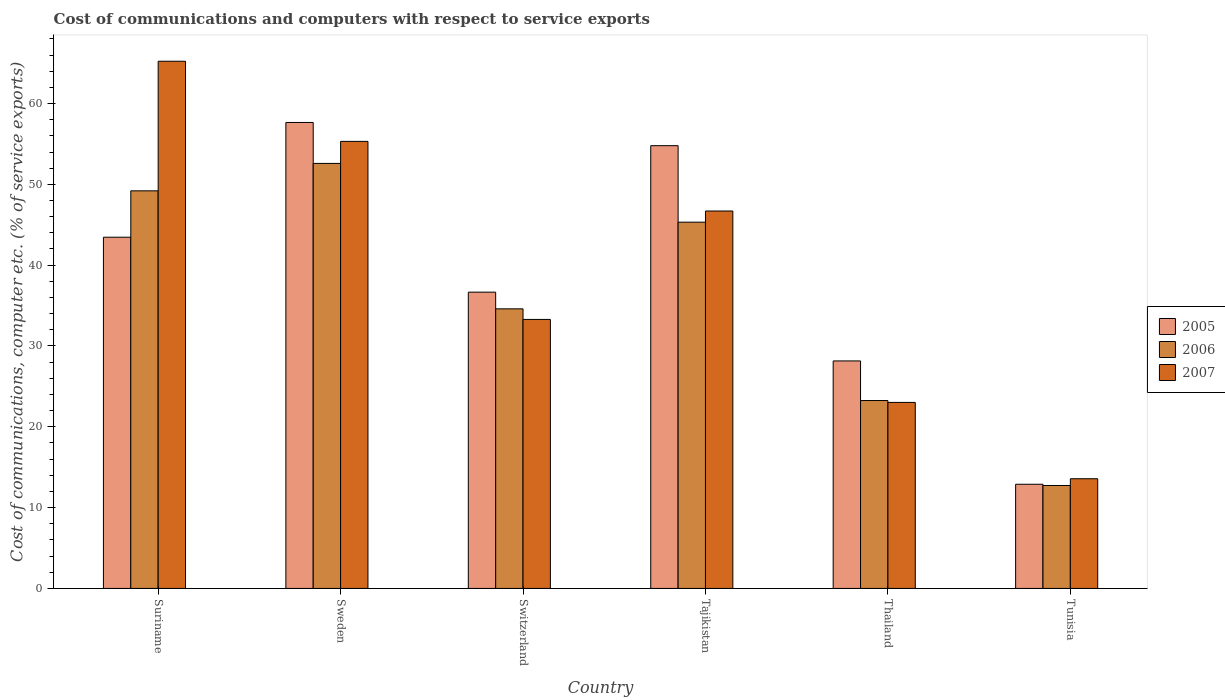How many different coloured bars are there?
Offer a very short reply. 3. How many groups of bars are there?
Your answer should be compact. 6. What is the label of the 6th group of bars from the left?
Give a very brief answer. Tunisia. In how many cases, is the number of bars for a given country not equal to the number of legend labels?
Offer a very short reply. 0. What is the cost of communications and computers in 2005 in Switzerland?
Ensure brevity in your answer.  36.66. Across all countries, what is the maximum cost of communications and computers in 2005?
Your answer should be compact. 57.66. Across all countries, what is the minimum cost of communications and computers in 2007?
Make the answer very short. 13.57. In which country was the cost of communications and computers in 2007 maximum?
Ensure brevity in your answer.  Suriname. In which country was the cost of communications and computers in 2005 minimum?
Give a very brief answer. Tunisia. What is the total cost of communications and computers in 2007 in the graph?
Offer a terse response. 237.13. What is the difference between the cost of communications and computers in 2006 in Thailand and that in Tunisia?
Offer a very short reply. 10.51. What is the difference between the cost of communications and computers in 2006 in Tunisia and the cost of communications and computers in 2005 in Thailand?
Offer a very short reply. -15.41. What is the average cost of communications and computers in 2007 per country?
Keep it short and to the point. 39.52. What is the difference between the cost of communications and computers of/in 2006 and cost of communications and computers of/in 2007 in Tajikistan?
Ensure brevity in your answer.  -1.38. In how many countries, is the cost of communications and computers in 2006 greater than 18 %?
Provide a short and direct response. 5. What is the ratio of the cost of communications and computers in 2005 in Switzerland to that in Tajikistan?
Provide a succinct answer. 0.67. Is the cost of communications and computers in 2005 in Suriname less than that in Thailand?
Provide a succinct answer. No. What is the difference between the highest and the second highest cost of communications and computers in 2007?
Give a very brief answer. 18.53. What is the difference between the highest and the lowest cost of communications and computers in 2006?
Keep it short and to the point. 39.85. Is the sum of the cost of communications and computers in 2006 in Suriname and Sweden greater than the maximum cost of communications and computers in 2005 across all countries?
Keep it short and to the point. Yes. What does the 1st bar from the left in Tunisia represents?
Give a very brief answer. 2005. What does the 3rd bar from the right in Sweden represents?
Offer a very short reply. 2005. Is it the case that in every country, the sum of the cost of communications and computers in 2006 and cost of communications and computers in 2007 is greater than the cost of communications and computers in 2005?
Your answer should be very brief. Yes. How many bars are there?
Give a very brief answer. 18. Are all the bars in the graph horizontal?
Provide a succinct answer. No. How many countries are there in the graph?
Provide a succinct answer. 6. What is the difference between two consecutive major ticks on the Y-axis?
Keep it short and to the point. 10. Are the values on the major ticks of Y-axis written in scientific E-notation?
Keep it short and to the point. No. Does the graph contain grids?
Offer a terse response. No. How many legend labels are there?
Provide a short and direct response. 3. What is the title of the graph?
Your answer should be very brief. Cost of communications and computers with respect to service exports. Does "1982" appear as one of the legend labels in the graph?
Provide a short and direct response. No. What is the label or title of the X-axis?
Keep it short and to the point. Country. What is the label or title of the Y-axis?
Offer a very short reply. Cost of communications, computer etc. (% of service exports). What is the Cost of communications, computer etc. (% of service exports) of 2005 in Suriname?
Offer a very short reply. 43.46. What is the Cost of communications, computer etc. (% of service exports) in 2006 in Suriname?
Your answer should be very brief. 49.2. What is the Cost of communications, computer etc. (% of service exports) in 2007 in Suriname?
Give a very brief answer. 65.23. What is the Cost of communications, computer etc. (% of service exports) of 2005 in Sweden?
Provide a succinct answer. 57.66. What is the Cost of communications, computer etc. (% of service exports) of 2006 in Sweden?
Offer a very short reply. 52.59. What is the Cost of communications, computer etc. (% of service exports) of 2007 in Sweden?
Provide a succinct answer. 55.32. What is the Cost of communications, computer etc. (% of service exports) in 2005 in Switzerland?
Give a very brief answer. 36.66. What is the Cost of communications, computer etc. (% of service exports) in 2006 in Switzerland?
Provide a succinct answer. 34.6. What is the Cost of communications, computer etc. (% of service exports) in 2007 in Switzerland?
Provide a short and direct response. 33.29. What is the Cost of communications, computer etc. (% of service exports) of 2005 in Tajikistan?
Provide a short and direct response. 54.78. What is the Cost of communications, computer etc. (% of service exports) in 2006 in Tajikistan?
Ensure brevity in your answer.  45.32. What is the Cost of communications, computer etc. (% of service exports) of 2007 in Tajikistan?
Your answer should be compact. 46.7. What is the Cost of communications, computer etc. (% of service exports) of 2005 in Thailand?
Your response must be concise. 28.15. What is the Cost of communications, computer etc. (% of service exports) of 2006 in Thailand?
Give a very brief answer. 23.25. What is the Cost of communications, computer etc. (% of service exports) in 2007 in Thailand?
Provide a succinct answer. 23.02. What is the Cost of communications, computer etc. (% of service exports) of 2005 in Tunisia?
Provide a succinct answer. 12.89. What is the Cost of communications, computer etc. (% of service exports) in 2006 in Tunisia?
Your answer should be compact. 12.74. What is the Cost of communications, computer etc. (% of service exports) of 2007 in Tunisia?
Your answer should be compact. 13.57. Across all countries, what is the maximum Cost of communications, computer etc. (% of service exports) in 2005?
Make the answer very short. 57.66. Across all countries, what is the maximum Cost of communications, computer etc. (% of service exports) of 2006?
Your answer should be very brief. 52.59. Across all countries, what is the maximum Cost of communications, computer etc. (% of service exports) of 2007?
Make the answer very short. 65.23. Across all countries, what is the minimum Cost of communications, computer etc. (% of service exports) of 2005?
Your answer should be very brief. 12.89. Across all countries, what is the minimum Cost of communications, computer etc. (% of service exports) of 2006?
Your answer should be compact. 12.74. Across all countries, what is the minimum Cost of communications, computer etc. (% of service exports) in 2007?
Make the answer very short. 13.57. What is the total Cost of communications, computer etc. (% of service exports) in 2005 in the graph?
Your response must be concise. 233.6. What is the total Cost of communications, computer etc. (% of service exports) in 2006 in the graph?
Offer a very short reply. 217.69. What is the total Cost of communications, computer etc. (% of service exports) in 2007 in the graph?
Provide a succinct answer. 237.13. What is the difference between the Cost of communications, computer etc. (% of service exports) of 2005 in Suriname and that in Sweden?
Your answer should be compact. -14.2. What is the difference between the Cost of communications, computer etc. (% of service exports) in 2006 in Suriname and that in Sweden?
Make the answer very short. -3.39. What is the difference between the Cost of communications, computer etc. (% of service exports) in 2007 in Suriname and that in Sweden?
Make the answer very short. 9.92. What is the difference between the Cost of communications, computer etc. (% of service exports) of 2005 in Suriname and that in Switzerland?
Make the answer very short. 6.8. What is the difference between the Cost of communications, computer etc. (% of service exports) in 2006 in Suriname and that in Switzerland?
Offer a terse response. 14.6. What is the difference between the Cost of communications, computer etc. (% of service exports) of 2007 in Suriname and that in Switzerland?
Give a very brief answer. 31.95. What is the difference between the Cost of communications, computer etc. (% of service exports) of 2005 in Suriname and that in Tajikistan?
Provide a short and direct response. -11.33. What is the difference between the Cost of communications, computer etc. (% of service exports) in 2006 in Suriname and that in Tajikistan?
Offer a terse response. 3.88. What is the difference between the Cost of communications, computer etc. (% of service exports) in 2007 in Suriname and that in Tajikistan?
Ensure brevity in your answer.  18.53. What is the difference between the Cost of communications, computer etc. (% of service exports) in 2005 in Suriname and that in Thailand?
Give a very brief answer. 15.31. What is the difference between the Cost of communications, computer etc. (% of service exports) in 2006 in Suriname and that in Thailand?
Provide a short and direct response. 25.95. What is the difference between the Cost of communications, computer etc. (% of service exports) in 2007 in Suriname and that in Thailand?
Your response must be concise. 42.22. What is the difference between the Cost of communications, computer etc. (% of service exports) in 2005 in Suriname and that in Tunisia?
Offer a very short reply. 30.57. What is the difference between the Cost of communications, computer etc. (% of service exports) in 2006 in Suriname and that in Tunisia?
Provide a succinct answer. 36.46. What is the difference between the Cost of communications, computer etc. (% of service exports) in 2007 in Suriname and that in Tunisia?
Make the answer very short. 51.66. What is the difference between the Cost of communications, computer etc. (% of service exports) in 2005 in Sweden and that in Switzerland?
Provide a succinct answer. 20.99. What is the difference between the Cost of communications, computer etc. (% of service exports) in 2006 in Sweden and that in Switzerland?
Make the answer very short. 17.99. What is the difference between the Cost of communications, computer etc. (% of service exports) in 2007 in Sweden and that in Switzerland?
Keep it short and to the point. 22.03. What is the difference between the Cost of communications, computer etc. (% of service exports) of 2005 in Sweden and that in Tajikistan?
Give a very brief answer. 2.87. What is the difference between the Cost of communications, computer etc. (% of service exports) of 2006 in Sweden and that in Tajikistan?
Your answer should be compact. 7.27. What is the difference between the Cost of communications, computer etc. (% of service exports) in 2007 in Sweden and that in Tajikistan?
Keep it short and to the point. 8.61. What is the difference between the Cost of communications, computer etc. (% of service exports) in 2005 in Sweden and that in Thailand?
Provide a succinct answer. 29.51. What is the difference between the Cost of communications, computer etc. (% of service exports) in 2006 in Sweden and that in Thailand?
Keep it short and to the point. 29.34. What is the difference between the Cost of communications, computer etc. (% of service exports) in 2007 in Sweden and that in Thailand?
Offer a terse response. 32.3. What is the difference between the Cost of communications, computer etc. (% of service exports) of 2005 in Sweden and that in Tunisia?
Provide a succinct answer. 44.77. What is the difference between the Cost of communications, computer etc. (% of service exports) in 2006 in Sweden and that in Tunisia?
Provide a succinct answer. 39.85. What is the difference between the Cost of communications, computer etc. (% of service exports) in 2007 in Sweden and that in Tunisia?
Keep it short and to the point. 41.74. What is the difference between the Cost of communications, computer etc. (% of service exports) of 2005 in Switzerland and that in Tajikistan?
Your answer should be compact. -18.12. What is the difference between the Cost of communications, computer etc. (% of service exports) of 2006 in Switzerland and that in Tajikistan?
Offer a very short reply. -10.72. What is the difference between the Cost of communications, computer etc. (% of service exports) in 2007 in Switzerland and that in Tajikistan?
Give a very brief answer. -13.42. What is the difference between the Cost of communications, computer etc. (% of service exports) in 2005 in Switzerland and that in Thailand?
Provide a succinct answer. 8.51. What is the difference between the Cost of communications, computer etc. (% of service exports) in 2006 in Switzerland and that in Thailand?
Your answer should be compact. 11.35. What is the difference between the Cost of communications, computer etc. (% of service exports) in 2007 in Switzerland and that in Thailand?
Your answer should be very brief. 10.27. What is the difference between the Cost of communications, computer etc. (% of service exports) of 2005 in Switzerland and that in Tunisia?
Offer a very short reply. 23.77. What is the difference between the Cost of communications, computer etc. (% of service exports) of 2006 in Switzerland and that in Tunisia?
Your response must be concise. 21.86. What is the difference between the Cost of communications, computer etc. (% of service exports) of 2007 in Switzerland and that in Tunisia?
Provide a short and direct response. 19.71. What is the difference between the Cost of communications, computer etc. (% of service exports) of 2005 in Tajikistan and that in Thailand?
Your answer should be compact. 26.64. What is the difference between the Cost of communications, computer etc. (% of service exports) in 2006 in Tajikistan and that in Thailand?
Offer a terse response. 22.07. What is the difference between the Cost of communications, computer etc. (% of service exports) of 2007 in Tajikistan and that in Thailand?
Your response must be concise. 23.68. What is the difference between the Cost of communications, computer etc. (% of service exports) in 2005 in Tajikistan and that in Tunisia?
Your answer should be compact. 41.89. What is the difference between the Cost of communications, computer etc. (% of service exports) of 2006 in Tajikistan and that in Tunisia?
Give a very brief answer. 32.58. What is the difference between the Cost of communications, computer etc. (% of service exports) of 2007 in Tajikistan and that in Tunisia?
Offer a terse response. 33.13. What is the difference between the Cost of communications, computer etc. (% of service exports) of 2005 in Thailand and that in Tunisia?
Ensure brevity in your answer.  15.26. What is the difference between the Cost of communications, computer etc. (% of service exports) in 2006 in Thailand and that in Tunisia?
Provide a short and direct response. 10.51. What is the difference between the Cost of communications, computer etc. (% of service exports) of 2007 in Thailand and that in Tunisia?
Make the answer very short. 9.44. What is the difference between the Cost of communications, computer etc. (% of service exports) of 2005 in Suriname and the Cost of communications, computer etc. (% of service exports) of 2006 in Sweden?
Give a very brief answer. -9.13. What is the difference between the Cost of communications, computer etc. (% of service exports) of 2005 in Suriname and the Cost of communications, computer etc. (% of service exports) of 2007 in Sweden?
Offer a very short reply. -11.86. What is the difference between the Cost of communications, computer etc. (% of service exports) of 2006 in Suriname and the Cost of communications, computer etc. (% of service exports) of 2007 in Sweden?
Offer a very short reply. -6.12. What is the difference between the Cost of communications, computer etc. (% of service exports) in 2005 in Suriname and the Cost of communications, computer etc. (% of service exports) in 2006 in Switzerland?
Offer a terse response. 8.86. What is the difference between the Cost of communications, computer etc. (% of service exports) of 2005 in Suriname and the Cost of communications, computer etc. (% of service exports) of 2007 in Switzerland?
Your response must be concise. 10.17. What is the difference between the Cost of communications, computer etc. (% of service exports) of 2006 in Suriname and the Cost of communications, computer etc. (% of service exports) of 2007 in Switzerland?
Your answer should be very brief. 15.91. What is the difference between the Cost of communications, computer etc. (% of service exports) of 2005 in Suriname and the Cost of communications, computer etc. (% of service exports) of 2006 in Tajikistan?
Make the answer very short. -1.86. What is the difference between the Cost of communications, computer etc. (% of service exports) of 2005 in Suriname and the Cost of communications, computer etc. (% of service exports) of 2007 in Tajikistan?
Give a very brief answer. -3.24. What is the difference between the Cost of communications, computer etc. (% of service exports) in 2006 in Suriname and the Cost of communications, computer etc. (% of service exports) in 2007 in Tajikistan?
Your answer should be very brief. 2.5. What is the difference between the Cost of communications, computer etc. (% of service exports) in 2005 in Suriname and the Cost of communications, computer etc. (% of service exports) in 2006 in Thailand?
Give a very brief answer. 20.21. What is the difference between the Cost of communications, computer etc. (% of service exports) in 2005 in Suriname and the Cost of communications, computer etc. (% of service exports) in 2007 in Thailand?
Offer a terse response. 20.44. What is the difference between the Cost of communications, computer etc. (% of service exports) of 2006 in Suriname and the Cost of communications, computer etc. (% of service exports) of 2007 in Thailand?
Your answer should be compact. 26.18. What is the difference between the Cost of communications, computer etc. (% of service exports) of 2005 in Suriname and the Cost of communications, computer etc. (% of service exports) of 2006 in Tunisia?
Keep it short and to the point. 30.72. What is the difference between the Cost of communications, computer etc. (% of service exports) of 2005 in Suriname and the Cost of communications, computer etc. (% of service exports) of 2007 in Tunisia?
Keep it short and to the point. 29.89. What is the difference between the Cost of communications, computer etc. (% of service exports) of 2006 in Suriname and the Cost of communications, computer etc. (% of service exports) of 2007 in Tunisia?
Your response must be concise. 35.62. What is the difference between the Cost of communications, computer etc. (% of service exports) of 2005 in Sweden and the Cost of communications, computer etc. (% of service exports) of 2006 in Switzerland?
Ensure brevity in your answer.  23.06. What is the difference between the Cost of communications, computer etc. (% of service exports) in 2005 in Sweden and the Cost of communications, computer etc. (% of service exports) in 2007 in Switzerland?
Offer a very short reply. 24.37. What is the difference between the Cost of communications, computer etc. (% of service exports) in 2006 in Sweden and the Cost of communications, computer etc. (% of service exports) in 2007 in Switzerland?
Ensure brevity in your answer.  19.3. What is the difference between the Cost of communications, computer etc. (% of service exports) of 2005 in Sweden and the Cost of communications, computer etc. (% of service exports) of 2006 in Tajikistan?
Ensure brevity in your answer.  12.34. What is the difference between the Cost of communications, computer etc. (% of service exports) in 2005 in Sweden and the Cost of communications, computer etc. (% of service exports) in 2007 in Tajikistan?
Your response must be concise. 10.96. What is the difference between the Cost of communications, computer etc. (% of service exports) of 2006 in Sweden and the Cost of communications, computer etc. (% of service exports) of 2007 in Tajikistan?
Your answer should be compact. 5.89. What is the difference between the Cost of communications, computer etc. (% of service exports) in 2005 in Sweden and the Cost of communications, computer etc. (% of service exports) in 2006 in Thailand?
Offer a very short reply. 34.41. What is the difference between the Cost of communications, computer etc. (% of service exports) of 2005 in Sweden and the Cost of communications, computer etc. (% of service exports) of 2007 in Thailand?
Your answer should be compact. 34.64. What is the difference between the Cost of communications, computer etc. (% of service exports) of 2006 in Sweden and the Cost of communications, computer etc. (% of service exports) of 2007 in Thailand?
Ensure brevity in your answer.  29.57. What is the difference between the Cost of communications, computer etc. (% of service exports) in 2005 in Sweden and the Cost of communications, computer etc. (% of service exports) in 2006 in Tunisia?
Ensure brevity in your answer.  44.92. What is the difference between the Cost of communications, computer etc. (% of service exports) of 2005 in Sweden and the Cost of communications, computer etc. (% of service exports) of 2007 in Tunisia?
Provide a succinct answer. 44.08. What is the difference between the Cost of communications, computer etc. (% of service exports) of 2006 in Sweden and the Cost of communications, computer etc. (% of service exports) of 2007 in Tunisia?
Keep it short and to the point. 39.02. What is the difference between the Cost of communications, computer etc. (% of service exports) in 2005 in Switzerland and the Cost of communications, computer etc. (% of service exports) in 2006 in Tajikistan?
Give a very brief answer. -8.66. What is the difference between the Cost of communications, computer etc. (% of service exports) in 2005 in Switzerland and the Cost of communications, computer etc. (% of service exports) in 2007 in Tajikistan?
Your response must be concise. -10.04. What is the difference between the Cost of communications, computer etc. (% of service exports) in 2006 in Switzerland and the Cost of communications, computer etc. (% of service exports) in 2007 in Tajikistan?
Ensure brevity in your answer.  -12.1. What is the difference between the Cost of communications, computer etc. (% of service exports) in 2005 in Switzerland and the Cost of communications, computer etc. (% of service exports) in 2006 in Thailand?
Offer a very short reply. 13.41. What is the difference between the Cost of communications, computer etc. (% of service exports) in 2005 in Switzerland and the Cost of communications, computer etc. (% of service exports) in 2007 in Thailand?
Your answer should be compact. 13.64. What is the difference between the Cost of communications, computer etc. (% of service exports) of 2006 in Switzerland and the Cost of communications, computer etc. (% of service exports) of 2007 in Thailand?
Make the answer very short. 11.58. What is the difference between the Cost of communications, computer etc. (% of service exports) of 2005 in Switzerland and the Cost of communications, computer etc. (% of service exports) of 2006 in Tunisia?
Offer a terse response. 23.92. What is the difference between the Cost of communications, computer etc. (% of service exports) of 2005 in Switzerland and the Cost of communications, computer etc. (% of service exports) of 2007 in Tunisia?
Make the answer very short. 23.09. What is the difference between the Cost of communications, computer etc. (% of service exports) of 2006 in Switzerland and the Cost of communications, computer etc. (% of service exports) of 2007 in Tunisia?
Ensure brevity in your answer.  21.02. What is the difference between the Cost of communications, computer etc. (% of service exports) of 2005 in Tajikistan and the Cost of communications, computer etc. (% of service exports) of 2006 in Thailand?
Provide a succinct answer. 31.53. What is the difference between the Cost of communications, computer etc. (% of service exports) of 2005 in Tajikistan and the Cost of communications, computer etc. (% of service exports) of 2007 in Thailand?
Offer a terse response. 31.77. What is the difference between the Cost of communications, computer etc. (% of service exports) of 2006 in Tajikistan and the Cost of communications, computer etc. (% of service exports) of 2007 in Thailand?
Make the answer very short. 22.3. What is the difference between the Cost of communications, computer etc. (% of service exports) of 2005 in Tajikistan and the Cost of communications, computer etc. (% of service exports) of 2006 in Tunisia?
Provide a short and direct response. 42.05. What is the difference between the Cost of communications, computer etc. (% of service exports) in 2005 in Tajikistan and the Cost of communications, computer etc. (% of service exports) in 2007 in Tunisia?
Your response must be concise. 41.21. What is the difference between the Cost of communications, computer etc. (% of service exports) of 2006 in Tajikistan and the Cost of communications, computer etc. (% of service exports) of 2007 in Tunisia?
Your response must be concise. 31.75. What is the difference between the Cost of communications, computer etc. (% of service exports) of 2005 in Thailand and the Cost of communications, computer etc. (% of service exports) of 2006 in Tunisia?
Your answer should be very brief. 15.41. What is the difference between the Cost of communications, computer etc. (% of service exports) of 2005 in Thailand and the Cost of communications, computer etc. (% of service exports) of 2007 in Tunisia?
Your answer should be compact. 14.58. What is the difference between the Cost of communications, computer etc. (% of service exports) in 2006 in Thailand and the Cost of communications, computer etc. (% of service exports) in 2007 in Tunisia?
Your answer should be very brief. 9.68. What is the average Cost of communications, computer etc. (% of service exports) in 2005 per country?
Offer a very short reply. 38.93. What is the average Cost of communications, computer etc. (% of service exports) in 2006 per country?
Keep it short and to the point. 36.28. What is the average Cost of communications, computer etc. (% of service exports) of 2007 per country?
Ensure brevity in your answer.  39.52. What is the difference between the Cost of communications, computer etc. (% of service exports) of 2005 and Cost of communications, computer etc. (% of service exports) of 2006 in Suriname?
Offer a very short reply. -5.74. What is the difference between the Cost of communications, computer etc. (% of service exports) of 2005 and Cost of communications, computer etc. (% of service exports) of 2007 in Suriname?
Give a very brief answer. -21.77. What is the difference between the Cost of communications, computer etc. (% of service exports) in 2006 and Cost of communications, computer etc. (% of service exports) in 2007 in Suriname?
Offer a terse response. -16.04. What is the difference between the Cost of communications, computer etc. (% of service exports) in 2005 and Cost of communications, computer etc. (% of service exports) in 2006 in Sweden?
Your answer should be very brief. 5.07. What is the difference between the Cost of communications, computer etc. (% of service exports) in 2005 and Cost of communications, computer etc. (% of service exports) in 2007 in Sweden?
Keep it short and to the point. 2.34. What is the difference between the Cost of communications, computer etc. (% of service exports) of 2006 and Cost of communications, computer etc. (% of service exports) of 2007 in Sweden?
Offer a very short reply. -2.73. What is the difference between the Cost of communications, computer etc. (% of service exports) in 2005 and Cost of communications, computer etc. (% of service exports) in 2006 in Switzerland?
Make the answer very short. 2.07. What is the difference between the Cost of communications, computer etc. (% of service exports) of 2005 and Cost of communications, computer etc. (% of service exports) of 2007 in Switzerland?
Provide a succinct answer. 3.38. What is the difference between the Cost of communications, computer etc. (% of service exports) in 2006 and Cost of communications, computer etc. (% of service exports) in 2007 in Switzerland?
Your answer should be very brief. 1.31. What is the difference between the Cost of communications, computer etc. (% of service exports) of 2005 and Cost of communications, computer etc. (% of service exports) of 2006 in Tajikistan?
Your answer should be very brief. 9.47. What is the difference between the Cost of communications, computer etc. (% of service exports) of 2005 and Cost of communications, computer etc. (% of service exports) of 2007 in Tajikistan?
Offer a terse response. 8.08. What is the difference between the Cost of communications, computer etc. (% of service exports) in 2006 and Cost of communications, computer etc. (% of service exports) in 2007 in Tajikistan?
Offer a very short reply. -1.38. What is the difference between the Cost of communications, computer etc. (% of service exports) of 2005 and Cost of communications, computer etc. (% of service exports) of 2006 in Thailand?
Your answer should be very brief. 4.9. What is the difference between the Cost of communications, computer etc. (% of service exports) in 2005 and Cost of communications, computer etc. (% of service exports) in 2007 in Thailand?
Your answer should be compact. 5.13. What is the difference between the Cost of communications, computer etc. (% of service exports) of 2006 and Cost of communications, computer etc. (% of service exports) of 2007 in Thailand?
Offer a very short reply. 0.23. What is the difference between the Cost of communications, computer etc. (% of service exports) in 2005 and Cost of communications, computer etc. (% of service exports) in 2006 in Tunisia?
Your answer should be very brief. 0.15. What is the difference between the Cost of communications, computer etc. (% of service exports) of 2005 and Cost of communications, computer etc. (% of service exports) of 2007 in Tunisia?
Give a very brief answer. -0.68. What is the difference between the Cost of communications, computer etc. (% of service exports) of 2006 and Cost of communications, computer etc. (% of service exports) of 2007 in Tunisia?
Provide a succinct answer. -0.84. What is the ratio of the Cost of communications, computer etc. (% of service exports) in 2005 in Suriname to that in Sweden?
Provide a short and direct response. 0.75. What is the ratio of the Cost of communications, computer etc. (% of service exports) in 2006 in Suriname to that in Sweden?
Your answer should be compact. 0.94. What is the ratio of the Cost of communications, computer etc. (% of service exports) in 2007 in Suriname to that in Sweden?
Provide a short and direct response. 1.18. What is the ratio of the Cost of communications, computer etc. (% of service exports) in 2005 in Suriname to that in Switzerland?
Offer a terse response. 1.19. What is the ratio of the Cost of communications, computer etc. (% of service exports) of 2006 in Suriname to that in Switzerland?
Your response must be concise. 1.42. What is the ratio of the Cost of communications, computer etc. (% of service exports) in 2007 in Suriname to that in Switzerland?
Offer a terse response. 1.96. What is the ratio of the Cost of communications, computer etc. (% of service exports) of 2005 in Suriname to that in Tajikistan?
Offer a terse response. 0.79. What is the ratio of the Cost of communications, computer etc. (% of service exports) of 2006 in Suriname to that in Tajikistan?
Offer a terse response. 1.09. What is the ratio of the Cost of communications, computer etc. (% of service exports) in 2007 in Suriname to that in Tajikistan?
Ensure brevity in your answer.  1.4. What is the ratio of the Cost of communications, computer etc. (% of service exports) in 2005 in Suriname to that in Thailand?
Keep it short and to the point. 1.54. What is the ratio of the Cost of communications, computer etc. (% of service exports) of 2006 in Suriname to that in Thailand?
Give a very brief answer. 2.12. What is the ratio of the Cost of communications, computer etc. (% of service exports) of 2007 in Suriname to that in Thailand?
Ensure brevity in your answer.  2.83. What is the ratio of the Cost of communications, computer etc. (% of service exports) in 2005 in Suriname to that in Tunisia?
Your answer should be compact. 3.37. What is the ratio of the Cost of communications, computer etc. (% of service exports) of 2006 in Suriname to that in Tunisia?
Provide a succinct answer. 3.86. What is the ratio of the Cost of communications, computer etc. (% of service exports) in 2007 in Suriname to that in Tunisia?
Ensure brevity in your answer.  4.81. What is the ratio of the Cost of communications, computer etc. (% of service exports) in 2005 in Sweden to that in Switzerland?
Provide a succinct answer. 1.57. What is the ratio of the Cost of communications, computer etc. (% of service exports) in 2006 in Sweden to that in Switzerland?
Keep it short and to the point. 1.52. What is the ratio of the Cost of communications, computer etc. (% of service exports) of 2007 in Sweden to that in Switzerland?
Keep it short and to the point. 1.66. What is the ratio of the Cost of communications, computer etc. (% of service exports) of 2005 in Sweden to that in Tajikistan?
Ensure brevity in your answer.  1.05. What is the ratio of the Cost of communications, computer etc. (% of service exports) in 2006 in Sweden to that in Tajikistan?
Offer a very short reply. 1.16. What is the ratio of the Cost of communications, computer etc. (% of service exports) in 2007 in Sweden to that in Tajikistan?
Make the answer very short. 1.18. What is the ratio of the Cost of communications, computer etc. (% of service exports) of 2005 in Sweden to that in Thailand?
Provide a succinct answer. 2.05. What is the ratio of the Cost of communications, computer etc. (% of service exports) of 2006 in Sweden to that in Thailand?
Your answer should be compact. 2.26. What is the ratio of the Cost of communications, computer etc. (% of service exports) in 2007 in Sweden to that in Thailand?
Your answer should be compact. 2.4. What is the ratio of the Cost of communications, computer etc. (% of service exports) in 2005 in Sweden to that in Tunisia?
Provide a succinct answer. 4.47. What is the ratio of the Cost of communications, computer etc. (% of service exports) in 2006 in Sweden to that in Tunisia?
Make the answer very short. 4.13. What is the ratio of the Cost of communications, computer etc. (% of service exports) in 2007 in Sweden to that in Tunisia?
Your response must be concise. 4.08. What is the ratio of the Cost of communications, computer etc. (% of service exports) in 2005 in Switzerland to that in Tajikistan?
Keep it short and to the point. 0.67. What is the ratio of the Cost of communications, computer etc. (% of service exports) of 2006 in Switzerland to that in Tajikistan?
Your response must be concise. 0.76. What is the ratio of the Cost of communications, computer etc. (% of service exports) of 2007 in Switzerland to that in Tajikistan?
Ensure brevity in your answer.  0.71. What is the ratio of the Cost of communications, computer etc. (% of service exports) in 2005 in Switzerland to that in Thailand?
Provide a short and direct response. 1.3. What is the ratio of the Cost of communications, computer etc. (% of service exports) in 2006 in Switzerland to that in Thailand?
Offer a terse response. 1.49. What is the ratio of the Cost of communications, computer etc. (% of service exports) in 2007 in Switzerland to that in Thailand?
Your response must be concise. 1.45. What is the ratio of the Cost of communications, computer etc. (% of service exports) in 2005 in Switzerland to that in Tunisia?
Your response must be concise. 2.84. What is the ratio of the Cost of communications, computer etc. (% of service exports) in 2006 in Switzerland to that in Tunisia?
Ensure brevity in your answer.  2.72. What is the ratio of the Cost of communications, computer etc. (% of service exports) in 2007 in Switzerland to that in Tunisia?
Your response must be concise. 2.45. What is the ratio of the Cost of communications, computer etc. (% of service exports) in 2005 in Tajikistan to that in Thailand?
Your response must be concise. 1.95. What is the ratio of the Cost of communications, computer etc. (% of service exports) in 2006 in Tajikistan to that in Thailand?
Ensure brevity in your answer.  1.95. What is the ratio of the Cost of communications, computer etc. (% of service exports) in 2007 in Tajikistan to that in Thailand?
Ensure brevity in your answer.  2.03. What is the ratio of the Cost of communications, computer etc. (% of service exports) of 2005 in Tajikistan to that in Tunisia?
Give a very brief answer. 4.25. What is the ratio of the Cost of communications, computer etc. (% of service exports) in 2006 in Tajikistan to that in Tunisia?
Make the answer very short. 3.56. What is the ratio of the Cost of communications, computer etc. (% of service exports) in 2007 in Tajikistan to that in Tunisia?
Your answer should be very brief. 3.44. What is the ratio of the Cost of communications, computer etc. (% of service exports) of 2005 in Thailand to that in Tunisia?
Offer a terse response. 2.18. What is the ratio of the Cost of communications, computer etc. (% of service exports) in 2006 in Thailand to that in Tunisia?
Make the answer very short. 1.83. What is the ratio of the Cost of communications, computer etc. (% of service exports) of 2007 in Thailand to that in Tunisia?
Offer a very short reply. 1.7. What is the difference between the highest and the second highest Cost of communications, computer etc. (% of service exports) in 2005?
Keep it short and to the point. 2.87. What is the difference between the highest and the second highest Cost of communications, computer etc. (% of service exports) in 2006?
Provide a succinct answer. 3.39. What is the difference between the highest and the second highest Cost of communications, computer etc. (% of service exports) of 2007?
Your answer should be compact. 9.92. What is the difference between the highest and the lowest Cost of communications, computer etc. (% of service exports) in 2005?
Keep it short and to the point. 44.77. What is the difference between the highest and the lowest Cost of communications, computer etc. (% of service exports) of 2006?
Offer a very short reply. 39.85. What is the difference between the highest and the lowest Cost of communications, computer etc. (% of service exports) in 2007?
Keep it short and to the point. 51.66. 